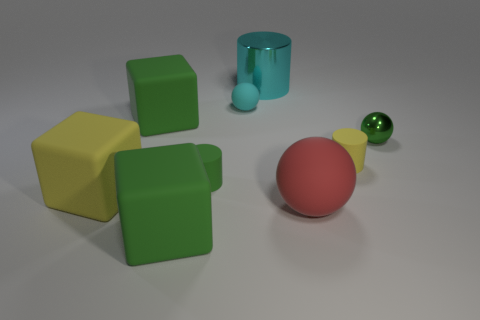What material is the green cylinder that is the same size as the yellow cylinder?
Keep it short and to the point. Rubber. Are there any yellow rubber balls that have the same size as the cyan shiny cylinder?
Your answer should be compact. No. There is a yellow rubber object that is the same size as the red object; what shape is it?
Keep it short and to the point. Cube. How many other objects are there of the same color as the large cylinder?
Your answer should be very brief. 1. The big object that is behind the metal sphere and in front of the big cyan metallic object has what shape?
Keep it short and to the point. Cube. Are there any yellow rubber things that are on the right side of the cylinder in front of the yellow rubber object on the right side of the large cyan thing?
Provide a short and direct response. Yes. What number of other objects are the same material as the tiny cyan object?
Give a very brief answer. 6. How many tiny gray rubber things are there?
Give a very brief answer. 0. What number of things are either tiny green cylinders or matte objects that are right of the large rubber ball?
Offer a very short reply. 2. Is there any other thing that is the same shape as the large cyan shiny object?
Your answer should be very brief. Yes. 